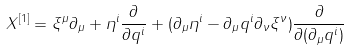<formula> <loc_0><loc_0><loc_500><loc_500>X ^ { [ 1 ] } = \xi ^ { \mu } \partial _ { \mu } + \eta ^ { i } \frac { \partial } { \partial q ^ { i } } + ( \partial _ { \mu } \eta ^ { i } - \partial _ { \mu } q ^ { i } \partial _ { \nu } \xi ^ { \nu } ) \frac { \partial } { \partial ( \partial _ { \mu } q ^ { i } ) }</formula> 